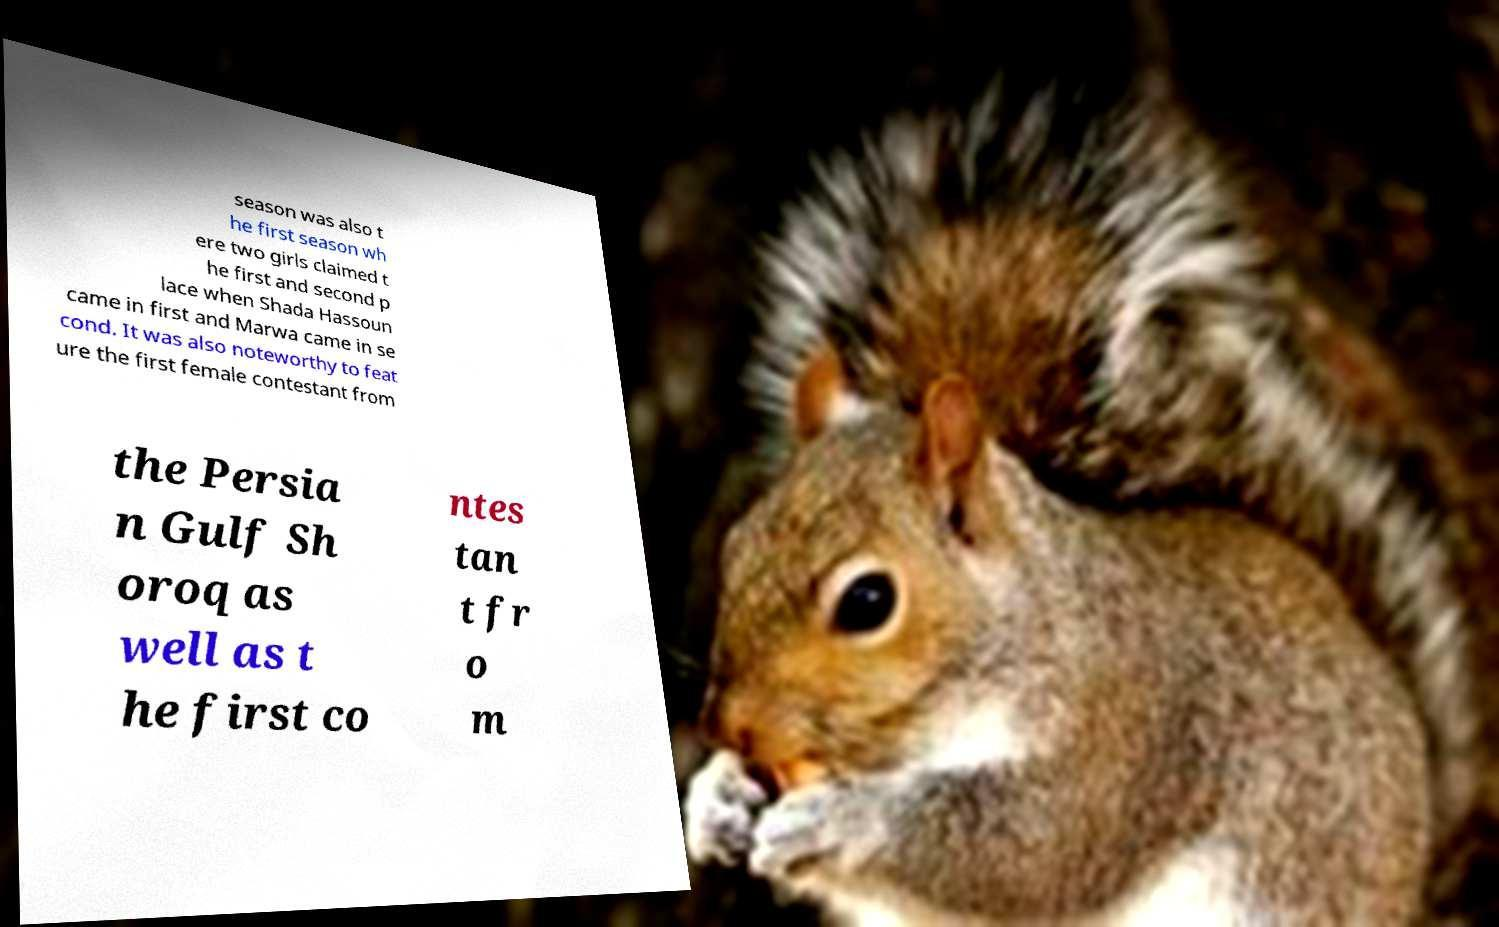Can you read and provide the text displayed in the image?This photo seems to have some interesting text. Can you extract and type it out for me? season was also t he first season wh ere two girls claimed t he first and second p lace when Shada Hassoun came in first and Marwa came in se cond. It was also noteworthy to feat ure the first female contestant from the Persia n Gulf Sh oroq as well as t he first co ntes tan t fr o m 